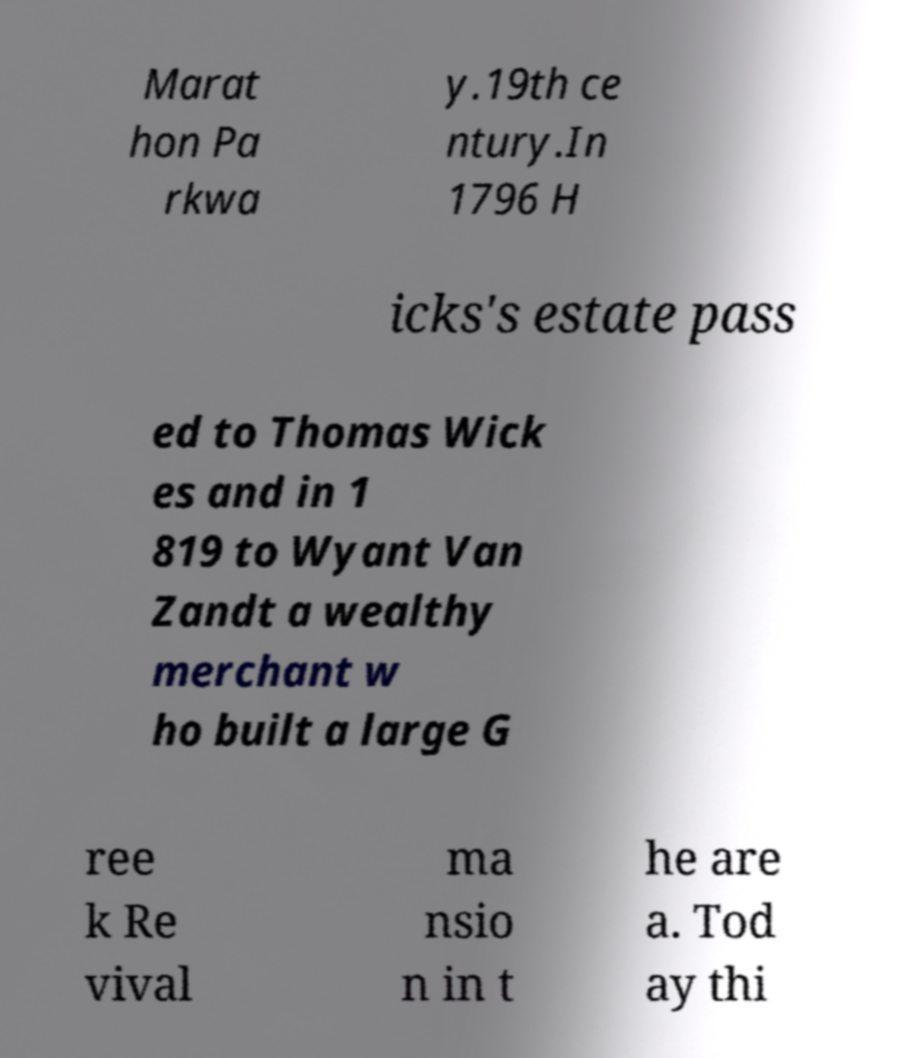Can you accurately transcribe the text from the provided image for me? Marat hon Pa rkwa y.19th ce ntury.In 1796 H icks's estate pass ed to Thomas Wick es and in 1 819 to Wyant Van Zandt a wealthy merchant w ho built a large G ree k Re vival ma nsio n in t he are a. Tod ay thi 